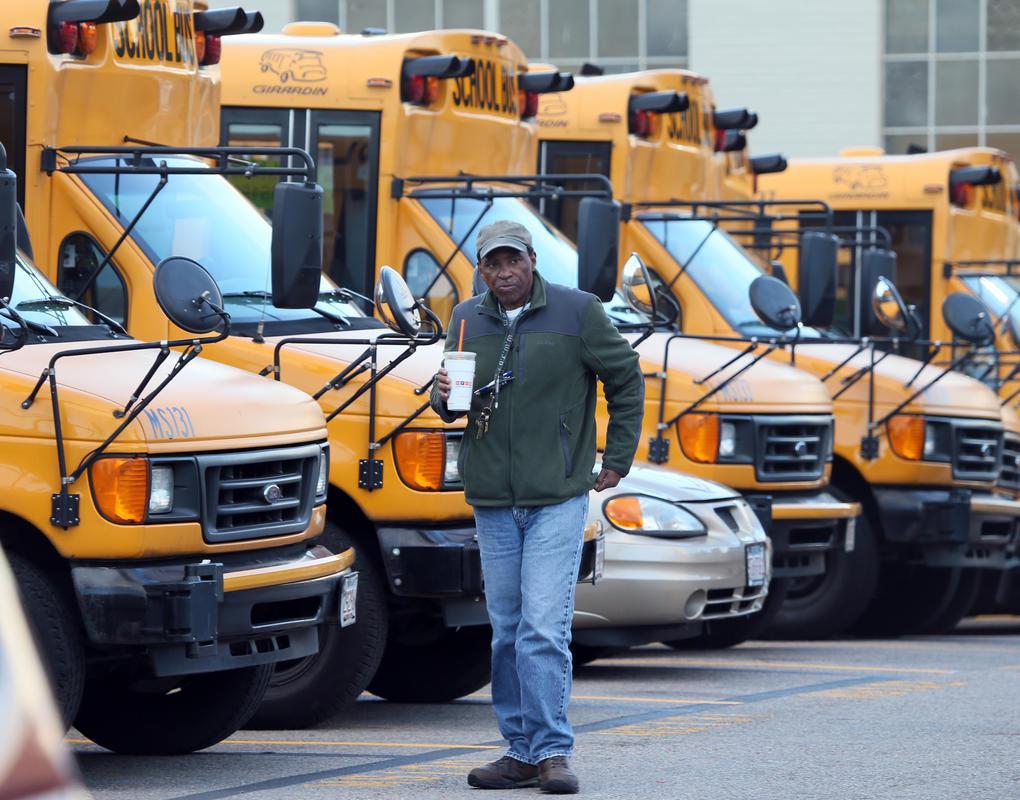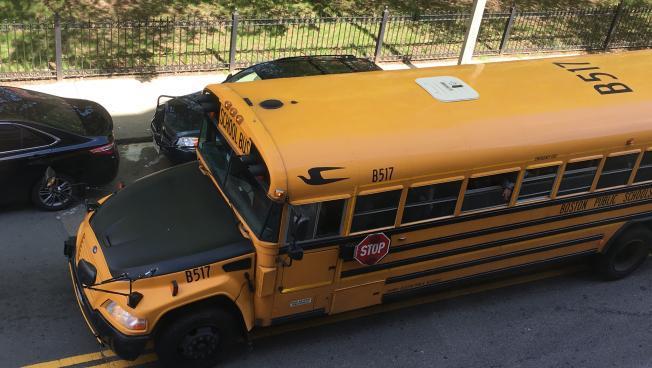The first image is the image on the left, the second image is the image on the right. Considering the images on both sides, is "In at least one image there is a single bus with a black hood facing forward left." valid? Answer yes or no. Yes. The first image is the image on the left, the second image is the image on the right. Given the left and right images, does the statement "There are people standing on the right side of the bus." hold true? Answer yes or no. No. 